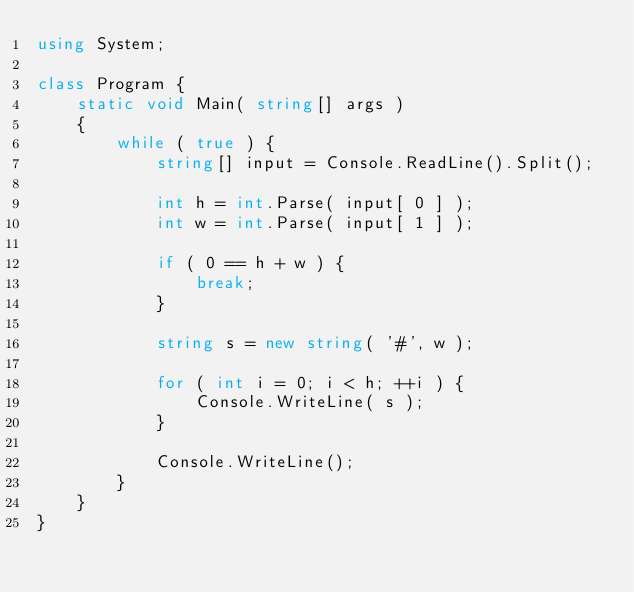Convert code to text. <code><loc_0><loc_0><loc_500><loc_500><_C#_>using System;

class Program {
    static void Main( string[] args )
    {
        while ( true ) {
            string[] input = Console.ReadLine().Split();

            int h = int.Parse( input[ 0 ] );
            int w = int.Parse( input[ 1 ] );

            if ( 0 == h + w ) {
                break;
            }

            string s = new string( '#', w );

            for ( int i = 0; i < h; ++i ) {
                Console.WriteLine( s );
            }

            Console.WriteLine();
        }
    }
}</code> 